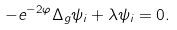<formula> <loc_0><loc_0><loc_500><loc_500>- e ^ { - 2 \varphi } \Delta _ { g } \psi _ { i } + \lambda \psi _ { i } = 0 .</formula> 